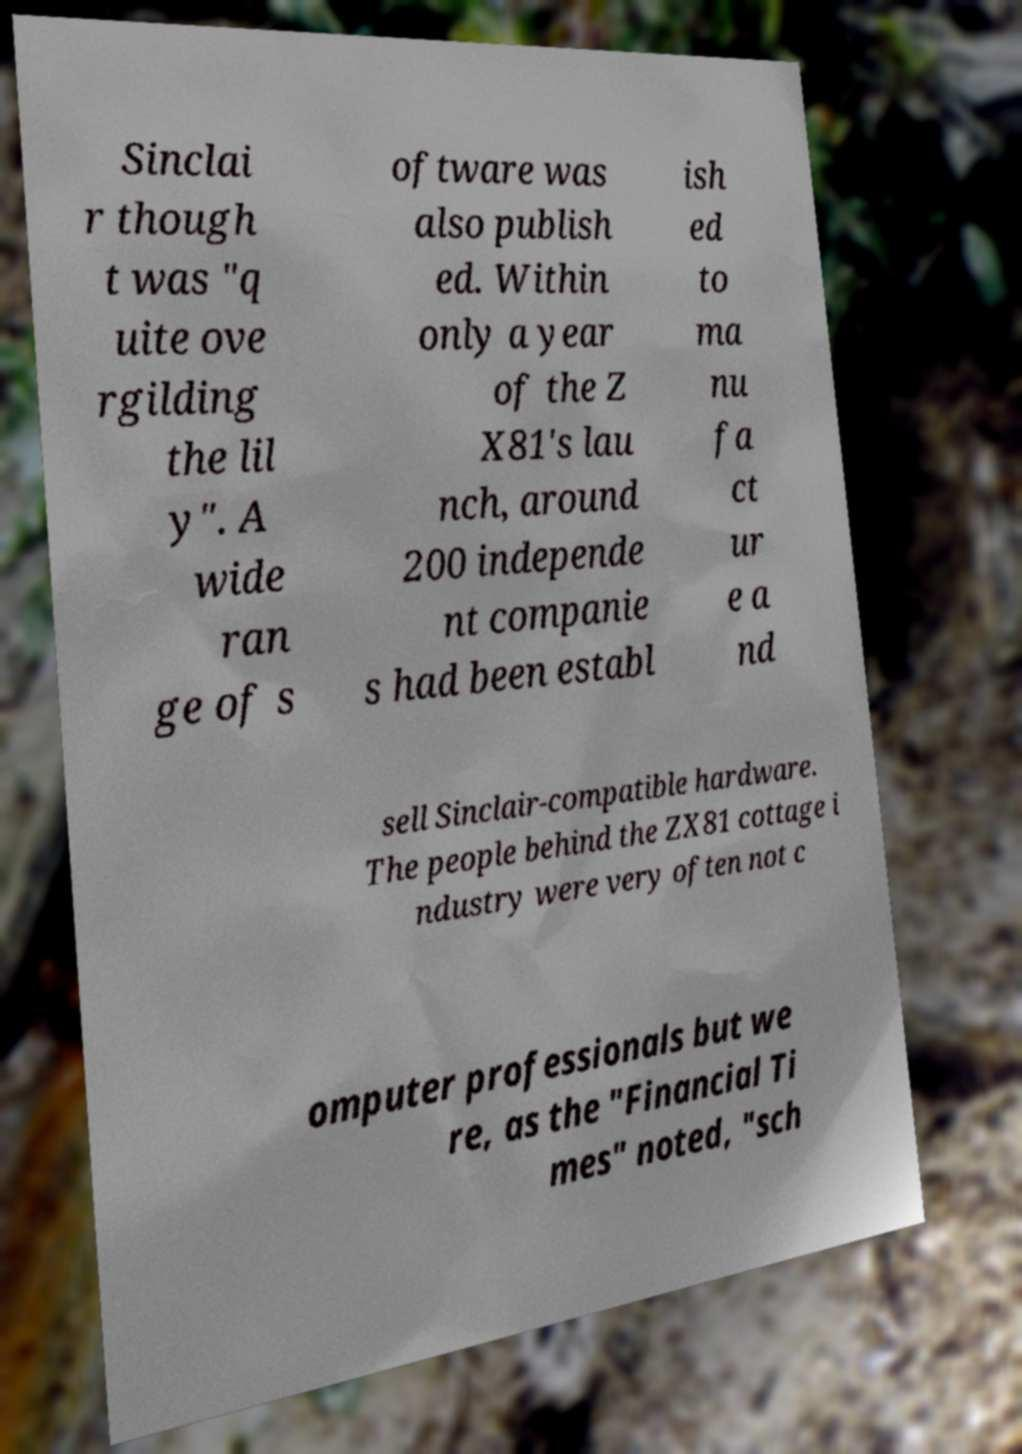There's text embedded in this image that I need extracted. Can you transcribe it verbatim? Sinclai r though t was "q uite ove rgilding the lil y". A wide ran ge of s oftware was also publish ed. Within only a year of the Z X81's lau nch, around 200 independe nt companie s had been establ ish ed to ma nu fa ct ur e a nd sell Sinclair-compatible hardware. The people behind the ZX81 cottage i ndustry were very often not c omputer professionals but we re, as the "Financial Ti mes" noted, "sch 